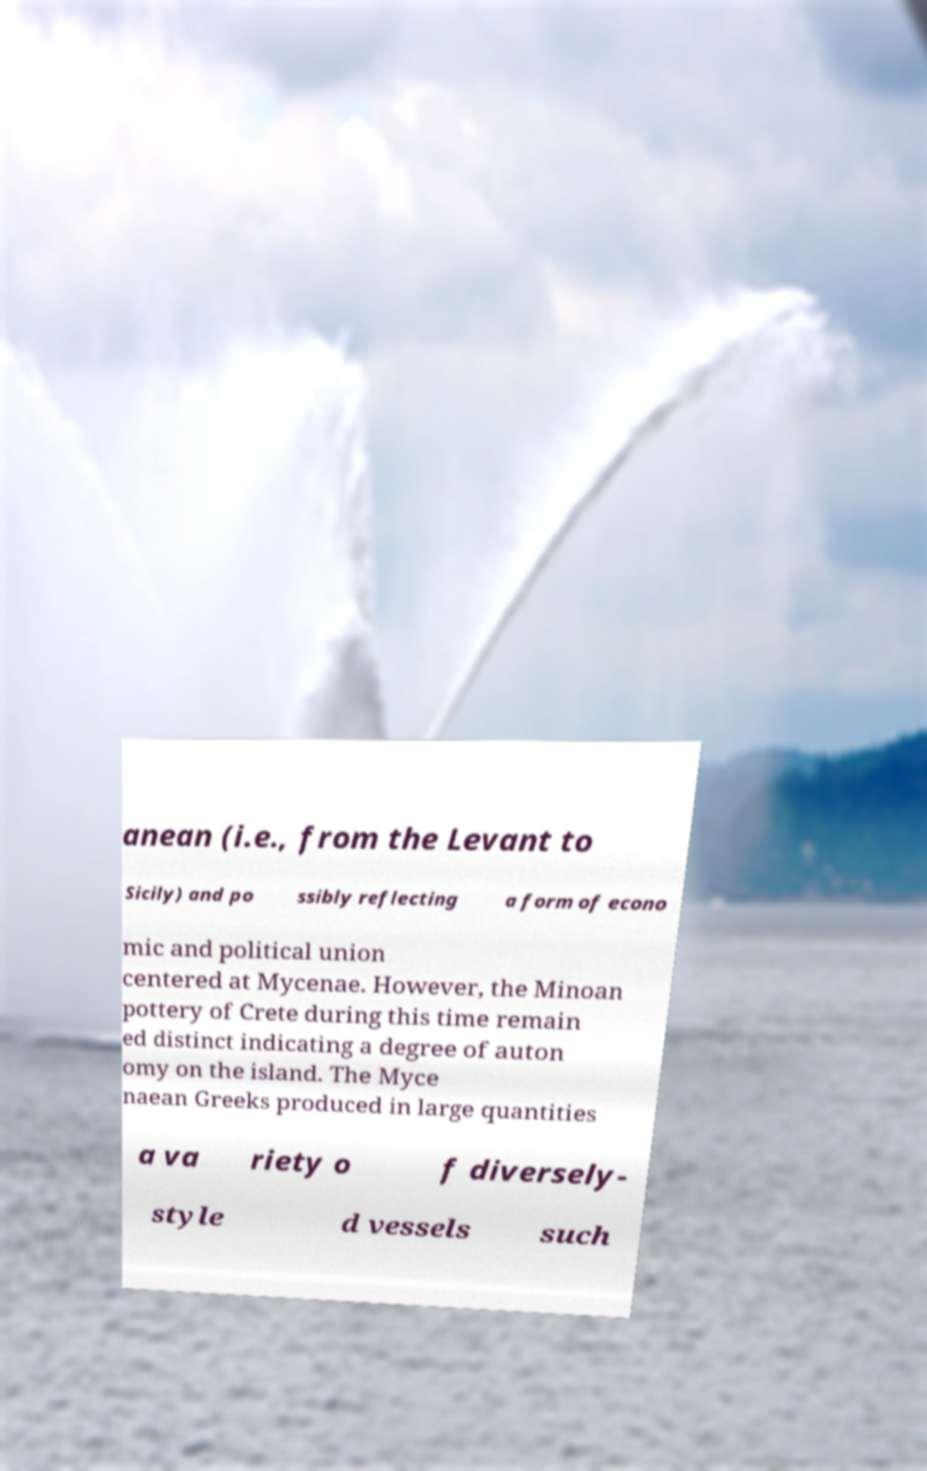Please read and relay the text visible in this image. What does it say? anean (i.e., from the Levant to Sicily) and po ssibly reflecting a form of econo mic and political union centered at Mycenae. However, the Minoan pottery of Crete during this time remain ed distinct indicating a degree of auton omy on the island. The Myce naean Greeks produced in large quantities a va riety o f diversely- style d vessels such 